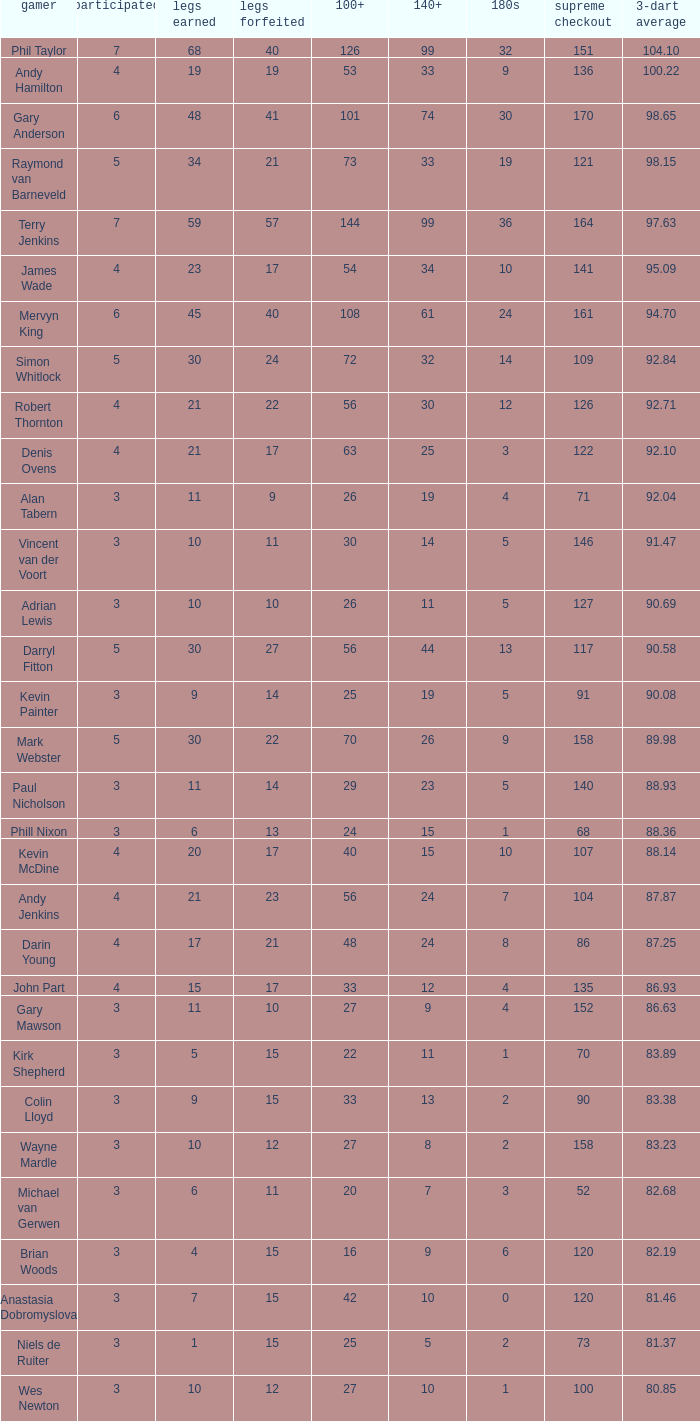Who is the player with 41 legs lost? Gary Anderson. Help me parse the entirety of this table. {'header': ['gamer', 'participated', 'legs earned', 'legs forfeited', '100+', '140+', '180s', 'supreme checkout', '3-dart average'], 'rows': [['Phil Taylor', '7', '68', '40', '126', '99', '32', '151', '104.10'], ['Andy Hamilton', '4', '19', '19', '53', '33', '9', '136', '100.22'], ['Gary Anderson', '6', '48', '41', '101', '74', '30', '170', '98.65'], ['Raymond van Barneveld', '5', '34', '21', '73', '33', '19', '121', '98.15'], ['Terry Jenkins', '7', '59', '57', '144', '99', '36', '164', '97.63'], ['James Wade', '4', '23', '17', '54', '34', '10', '141', '95.09'], ['Mervyn King', '6', '45', '40', '108', '61', '24', '161', '94.70'], ['Simon Whitlock', '5', '30', '24', '72', '32', '14', '109', '92.84'], ['Robert Thornton', '4', '21', '22', '56', '30', '12', '126', '92.71'], ['Denis Ovens', '4', '21', '17', '63', '25', '3', '122', '92.10'], ['Alan Tabern', '3', '11', '9', '26', '19', '4', '71', '92.04'], ['Vincent van der Voort', '3', '10', '11', '30', '14', '5', '146', '91.47'], ['Adrian Lewis', '3', '10', '10', '26', '11', '5', '127', '90.69'], ['Darryl Fitton', '5', '30', '27', '56', '44', '13', '117', '90.58'], ['Kevin Painter', '3', '9', '14', '25', '19', '5', '91', '90.08'], ['Mark Webster', '5', '30', '22', '70', '26', '9', '158', '89.98'], ['Paul Nicholson', '3', '11', '14', '29', '23', '5', '140', '88.93'], ['Phill Nixon', '3', '6', '13', '24', '15', '1', '68', '88.36'], ['Kevin McDine', '4', '20', '17', '40', '15', '10', '107', '88.14'], ['Andy Jenkins', '4', '21', '23', '56', '24', '7', '104', '87.87'], ['Darin Young', '4', '17', '21', '48', '24', '8', '86', '87.25'], ['John Part', '4', '15', '17', '33', '12', '4', '135', '86.93'], ['Gary Mawson', '3', '11', '10', '27', '9', '4', '152', '86.63'], ['Kirk Shepherd', '3', '5', '15', '22', '11', '1', '70', '83.89'], ['Colin Lloyd', '3', '9', '15', '33', '13', '2', '90', '83.38'], ['Wayne Mardle', '3', '10', '12', '27', '8', '2', '158', '83.23'], ['Michael van Gerwen', '3', '6', '11', '20', '7', '3', '52', '82.68'], ['Brian Woods', '3', '4', '15', '16', '9', '6', '120', '82.19'], ['Anastasia Dobromyslova', '3', '7', '15', '42', '10', '0', '120', '81.46'], ['Niels de Ruiter', '3', '1', '15', '25', '5', '2', '73', '81.37'], ['Wes Newton', '3', '10', '12', '27', '10', '1', '100', '80.85']]} 